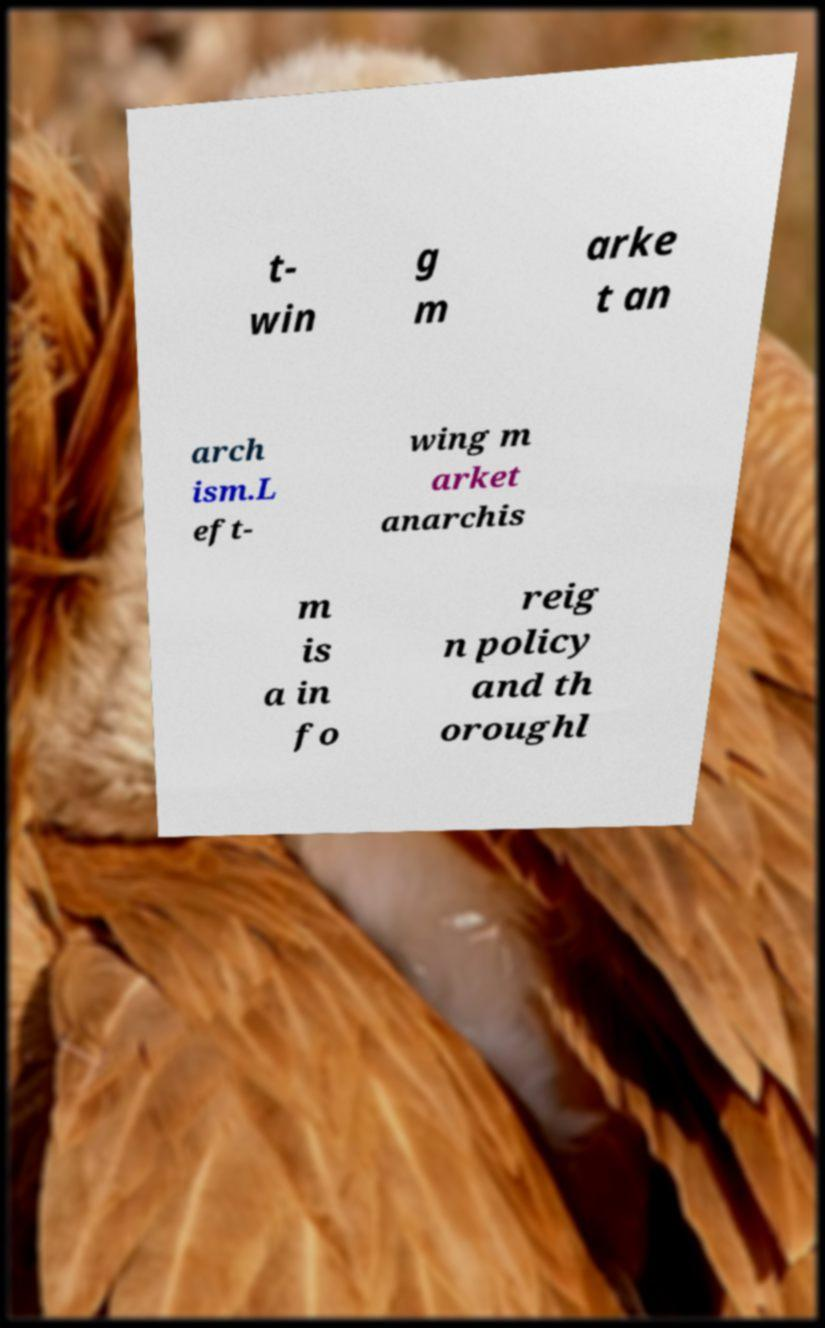Please read and relay the text visible in this image. What does it say? t- win g m arke t an arch ism.L eft- wing m arket anarchis m is a in fo reig n policy and th oroughl 